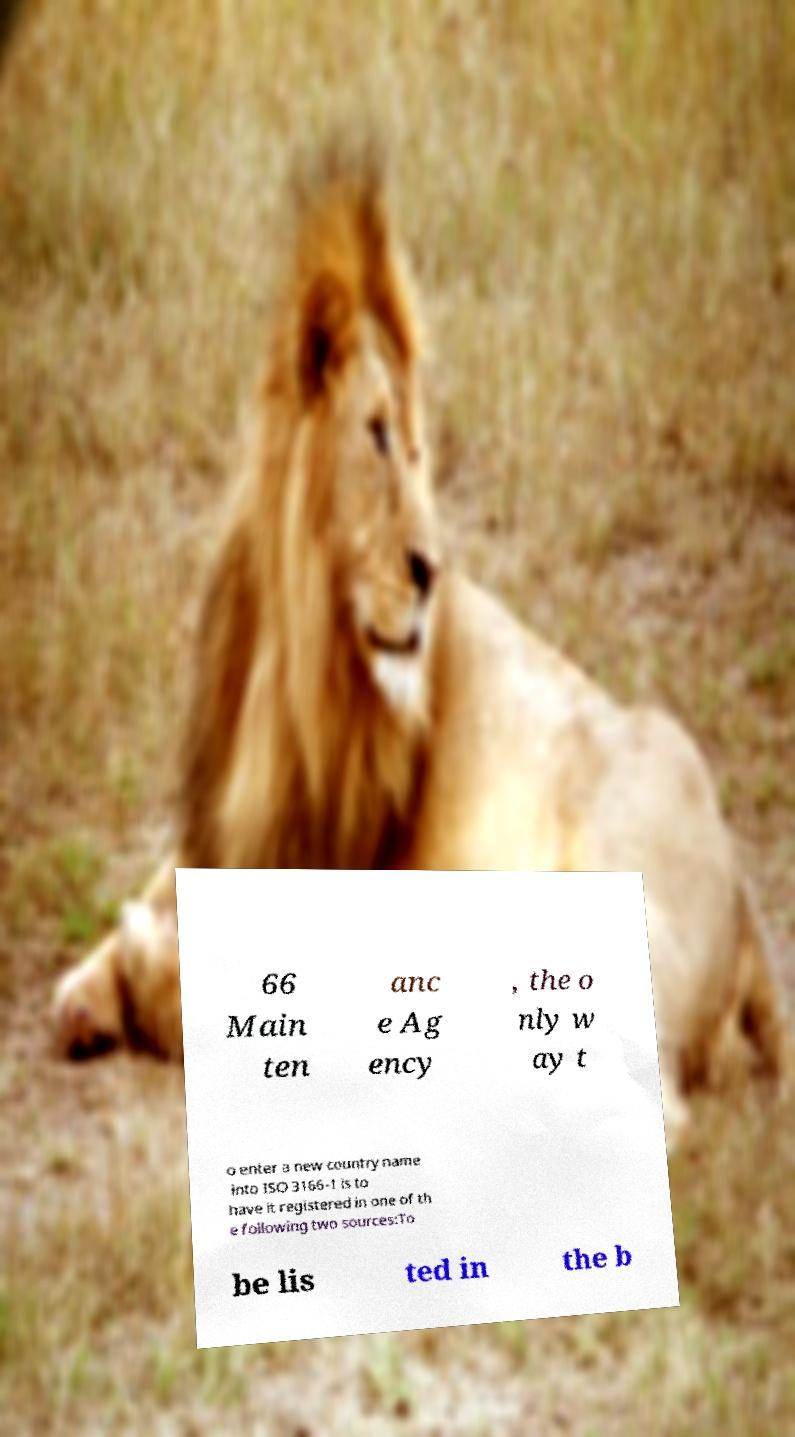Please read and relay the text visible in this image. What does it say? 66 Main ten anc e Ag ency , the o nly w ay t o enter a new country name into ISO 3166-1 is to have it registered in one of th e following two sources:To be lis ted in the b 